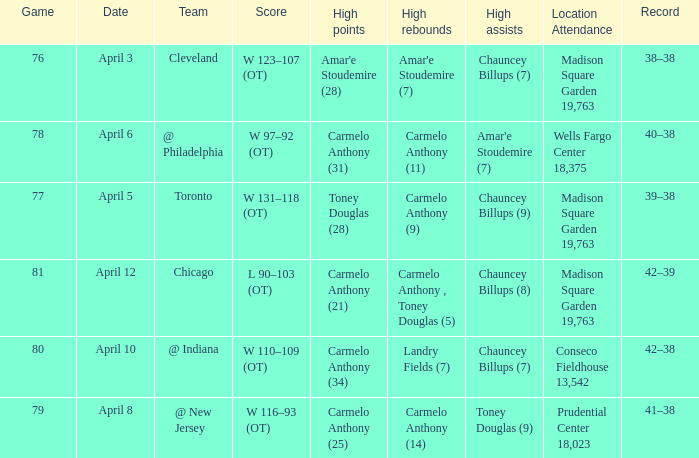Name the high assists for madison square garden 19,763 and record is 39–38 Chauncey Billups (9). 